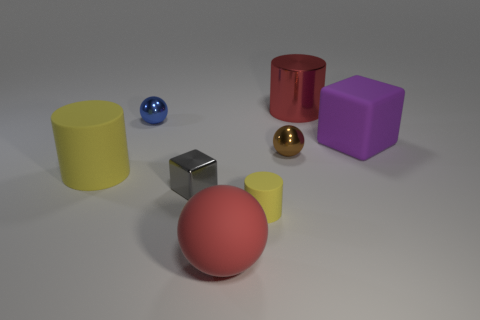Subtract 1 cylinders. How many cylinders are left? 2 Add 2 metallic spheres. How many objects exist? 10 Subtract all balls. How many objects are left? 5 Subtract all tiny gray metallic cubes. Subtract all large cubes. How many objects are left? 6 Add 4 large cubes. How many large cubes are left? 5 Add 7 tiny gray matte cylinders. How many tiny gray matte cylinders exist? 7 Subtract 1 gray blocks. How many objects are left? 7 